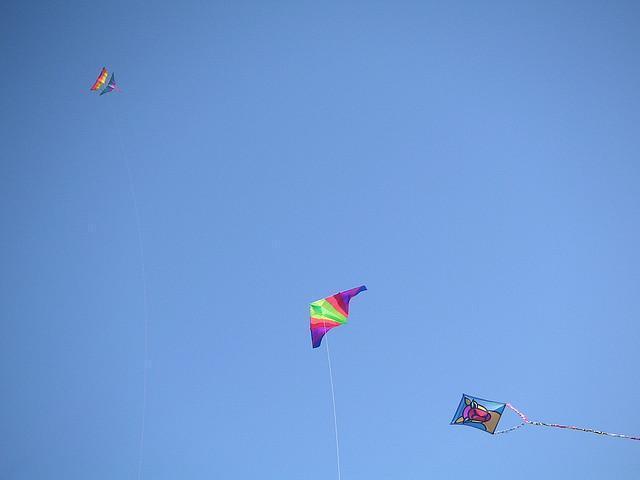How many items are in the photo?
Give a very brief answer. 3. How many kites are stringed together?
Give a very brief answer. 0. 